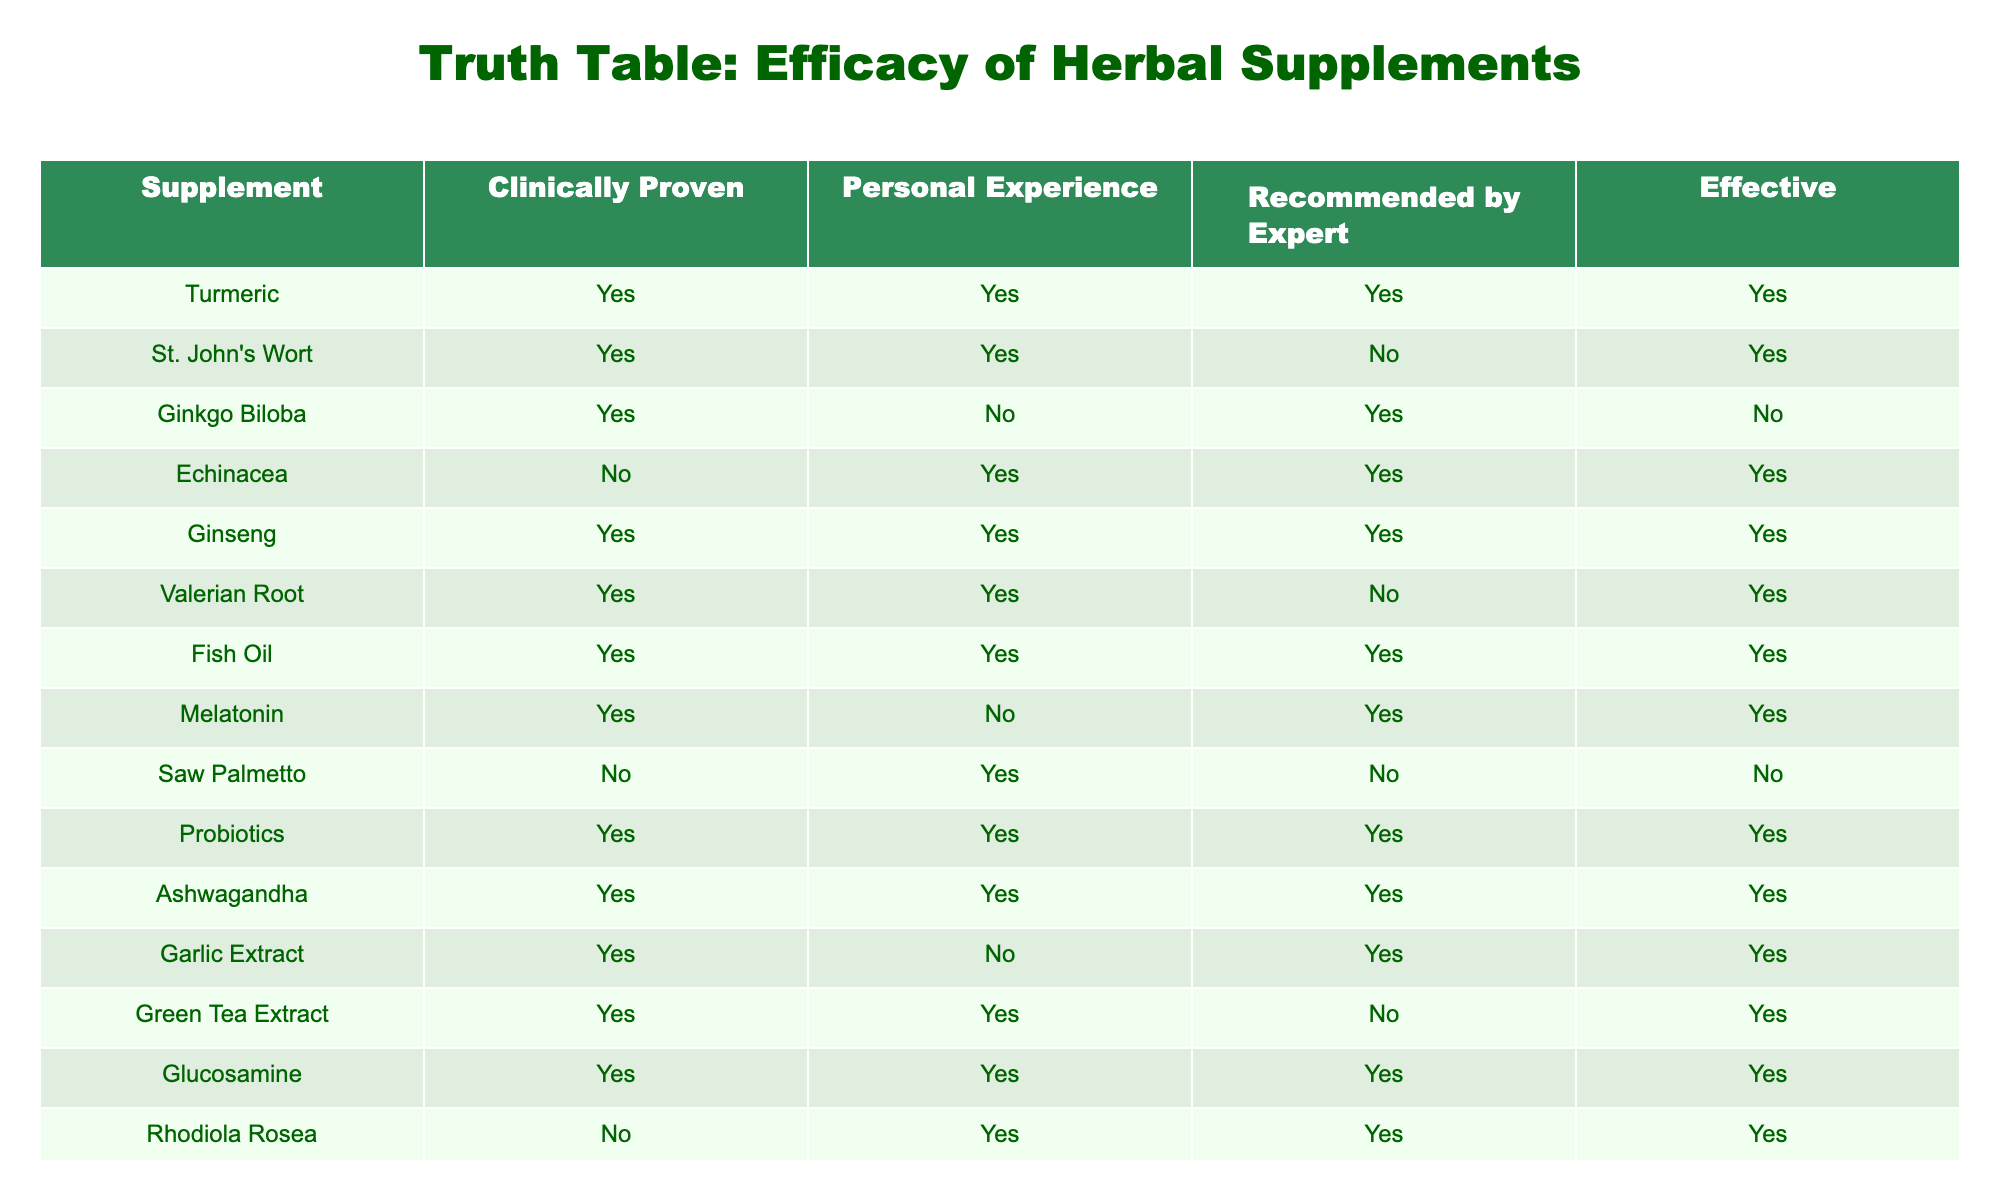What herbal supplement is both clinically proven and recommended by experts? Looking at the table, I can identify supplements that have a TRUE value for both the "Clinically Proven" and "Recommended by Expert" columns. These supplements are Turmeric, Echinacea, Ginseng, Probiotics, and Ashwagandha.
Answer: Turmeric, Echinacea, Ginseng, Probiotics, Ashwagandha Which supplement is effective but not clinically proven? To find this, I need to locate supplements that have TRUE in the "Effective" column but FALSE in the "Clinically Proven" column. Echinacea and Valerian Root meet this condition as they are marked effective but not clinically proven.
Answer: Echinacea, Valerian Root How many supplements are recommended for personal use and also proven effective? I will count the supplements that have a TRUE value for both "Personal Experience" and "Effective." By reviewing the table, I see that there are 8 such supplements: St. John's Wort, Echinacea, Ginseng, Valerian Root, Fish Oil, Probiotics, Ashwagandha, and Rhodiola Rosea.
Answer: 8 Is Ginkgo Biloba recommended by experts? Looking at the table, I can see the value for Ginkgo Biloba in the "Recommended by Expert" column is FALSE, which indicates it is not recommended by experts.
Answer: No What is the total number of supplements that are clinically proven? By examining the "Clinically Proven" column, I count the number of TRUE entries. The supplements that are clinically proven are Turmeric, St. John's Wort, Ginkgo Biloba, Ginseng, Valerian Root, Fish Oil, Probiotics, Ashwagandha, Garlic Extract, Green Tea Extract, Glucosamine, and Rhodiola Rosea, totaling 12 supplements.
Answer: 12 Which supplements are effective and not recommended by any experts? I need to identify supplements that have TRUE in the "Effective" column and FALSE in the "Recommended by Expert" column. From the data, the supplements that fit this criteria are St. John's Wort and Valerian Root.
Answer: St. John's Wort, Valerian Root Among the supplements listed, how many have both personal experience and expert recommendations indicating effectiveness? I will find supplements that have TRUE values in "Personal Experience" and "Recommended by Expert" columns and then check if they are also marked effective. The relevant supplements are Turmeric, Ginseng, Probiotics, and Ashwagandha, totaling 4 supplements that meet all criteria.
Answer: 4 Is Echinacea both clinically proven and effective? Checking the table, I find that Echinacea is marked as FALSE for "Clinically Proven" but TRUE for "Effective," indicating that while it is considered effective, it is not clinically proven.
Answer: No 